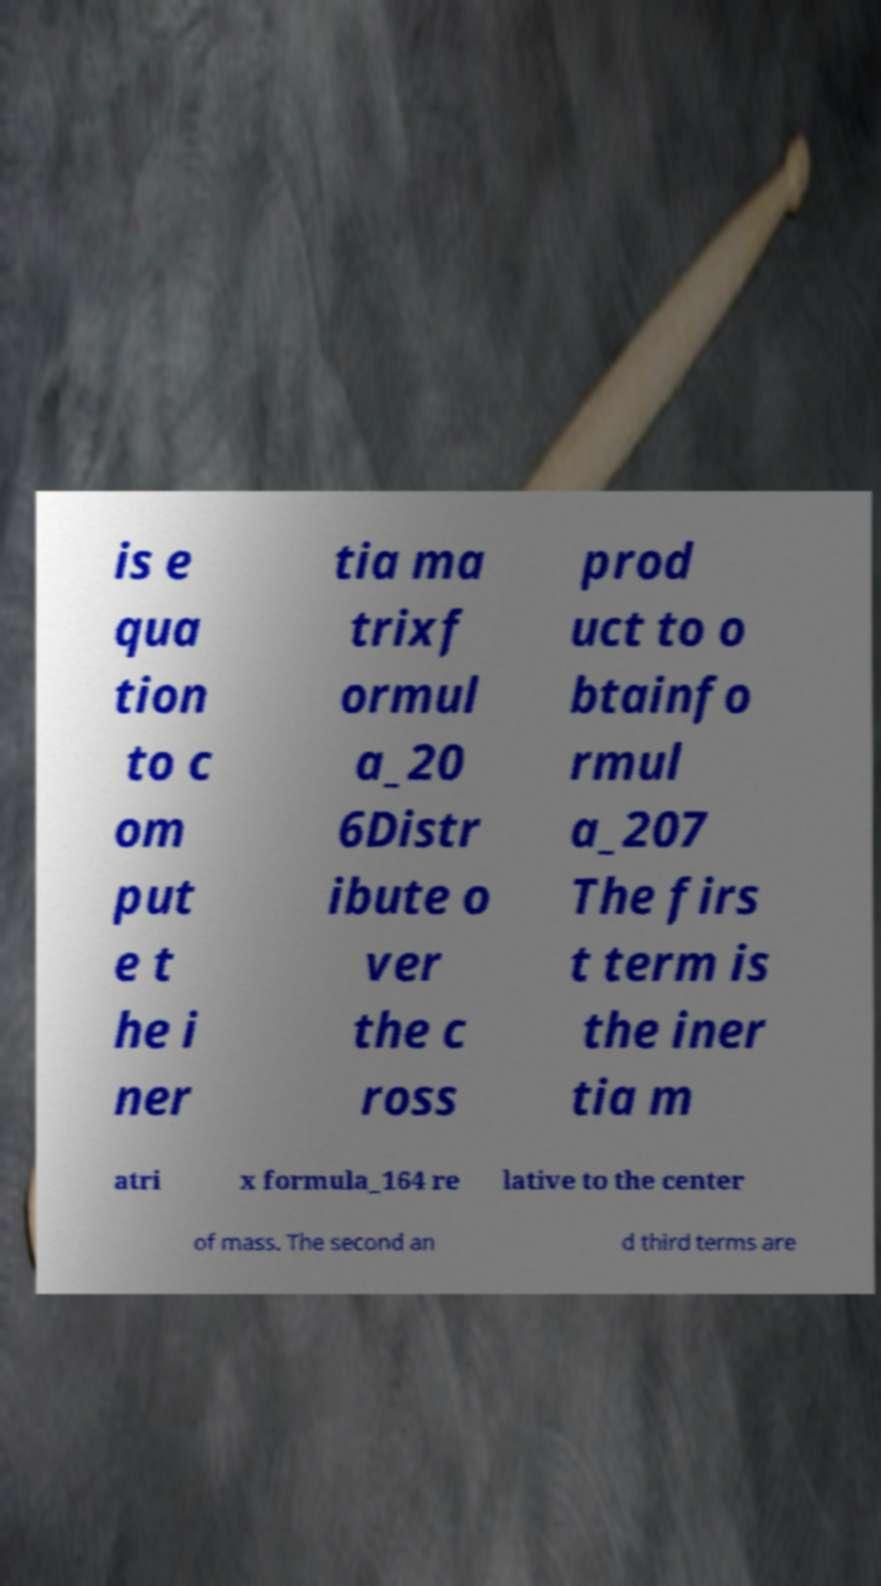Could you assist in decoding the text presented in this image and type it out clearly? is e qua tion to c om put e t he i ner tia ma trixf ormul a_20 6Distr ibute o ver the c ross prod uct to o btainfo rmul a_207 The firs t term is the iner tia m atri x formula_164 re lative to the center of mass. The second an d third terms are 